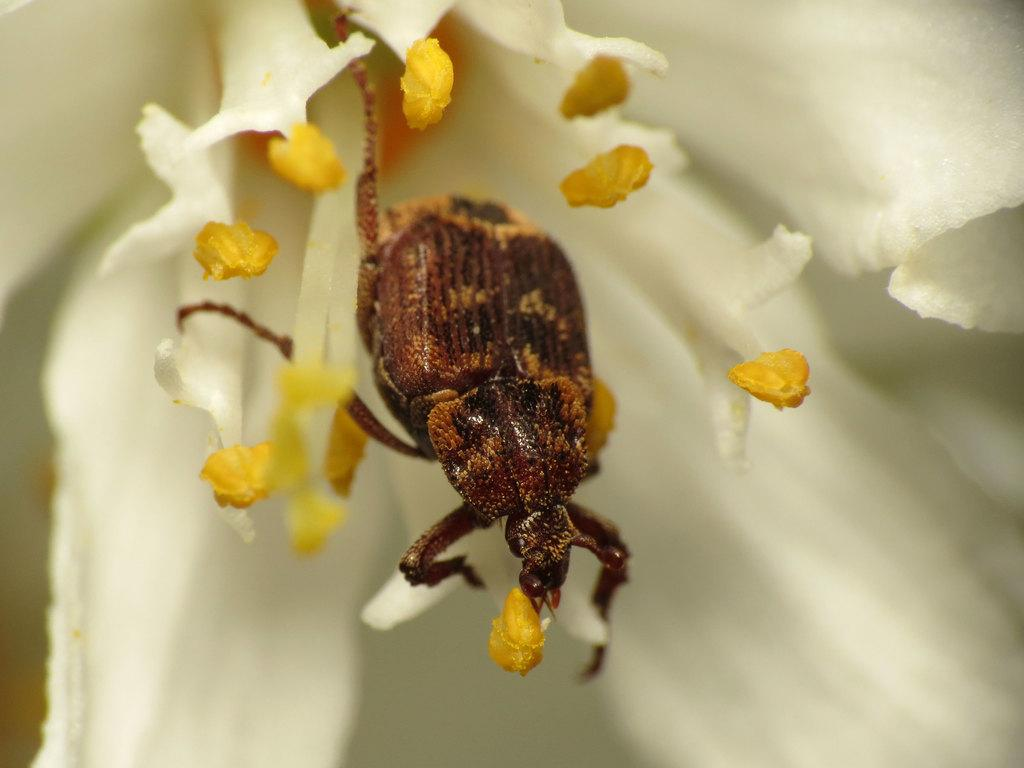What type of flower is in the image? There is a white flower in the image. Is there anything on the flower? Yes, there is an insect on the flower. What is the color of the insect? The insect is brown in color. What is the plot of the story unfolding in the image? There is no story or plot present in the image; it is a simple depiction of a white flower with an insect on it. What type of wind can be seen blowing in the image? There is no wind or zephyr present in the image. 